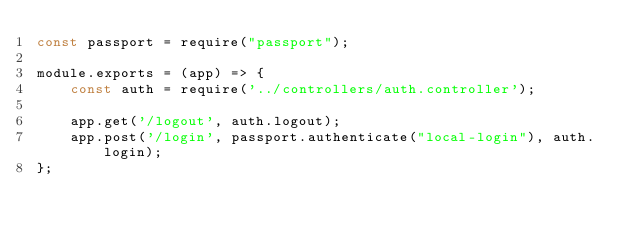Convert code to text. <code><loc_0><loc_0><loc_500><loc_500><_JavaScript_>const passport = require("passport");

module.exports = (app) => {
    const auth = require('../controllers/auth.controller');

    app.get('/logout', auth.logout);
    app.post('/login', passport.authenticate("local-login"), auth.login);
};</code> 